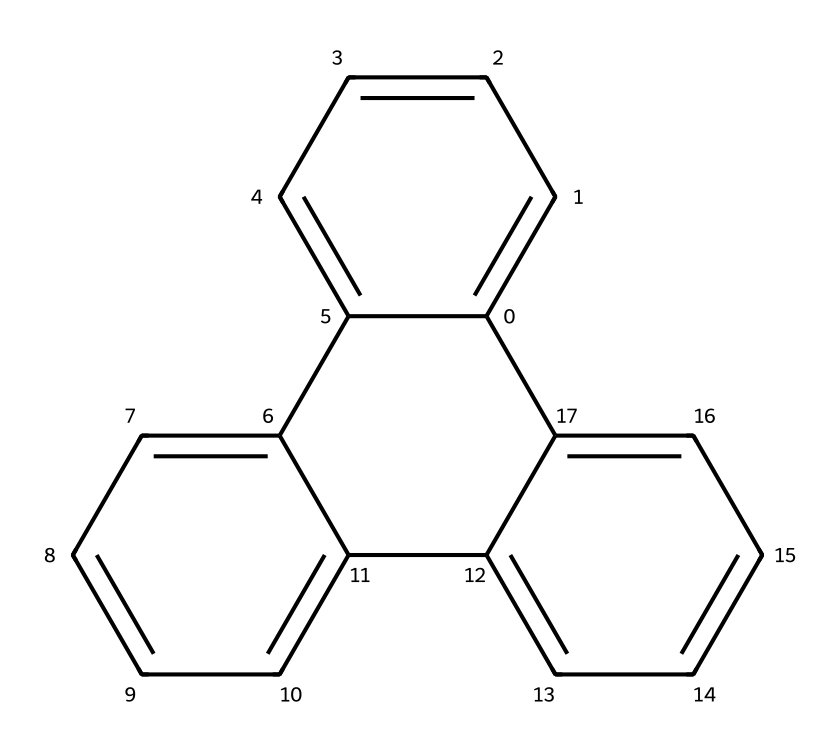What is the molecular formula of this compound? To find the molecular formula, we identify the number of carbon (C) and hydrogen (H) atoms in the structure. Counting the "C" and "H" symbols leads to a molecular formula of C18H18.
Answer: C18H18 How many carbon atoms are in this structure? The structure shows a total of 18 carbon atoms. By counting the vertices of the rings and accounting for the overall connectivity, you can confirm this count.
Answer: 18 What type of hybridization is present in the carbon atoms? The carbon atoms in this compound are primarily sp2 hybridized due to the presence of double bonds within the structure. Analyzing the bonding (one double bond and two single bonds for each carbon) indicates sp2 hybridization.
Answer: sp2 Is this molecule cyclic or acyclic? The presence of multiple interconnected carbon rings indicates that the structure is cyclic. By following the rings and their closures, it is clear that the molecule forms a cyclic structure.
Answer: cyclic What geometry do the carbon atoms adopt in this structure? The geometry around each carbon atom is trigonal planar due to the hybridization state of sp2. Observing the bond angles around each carbon gives an approximate 120-degree angle, characteristic of trigonal planar geometry.
Answer: trigonal planar Does this structure belong to the fullerene family? Yes, this structure is representative of fullerenes due to its spherical shape and carbon bonding. The arrangement of carbon atoms forming closed cages corresponds to typical fullerene features.
Answer: yes 